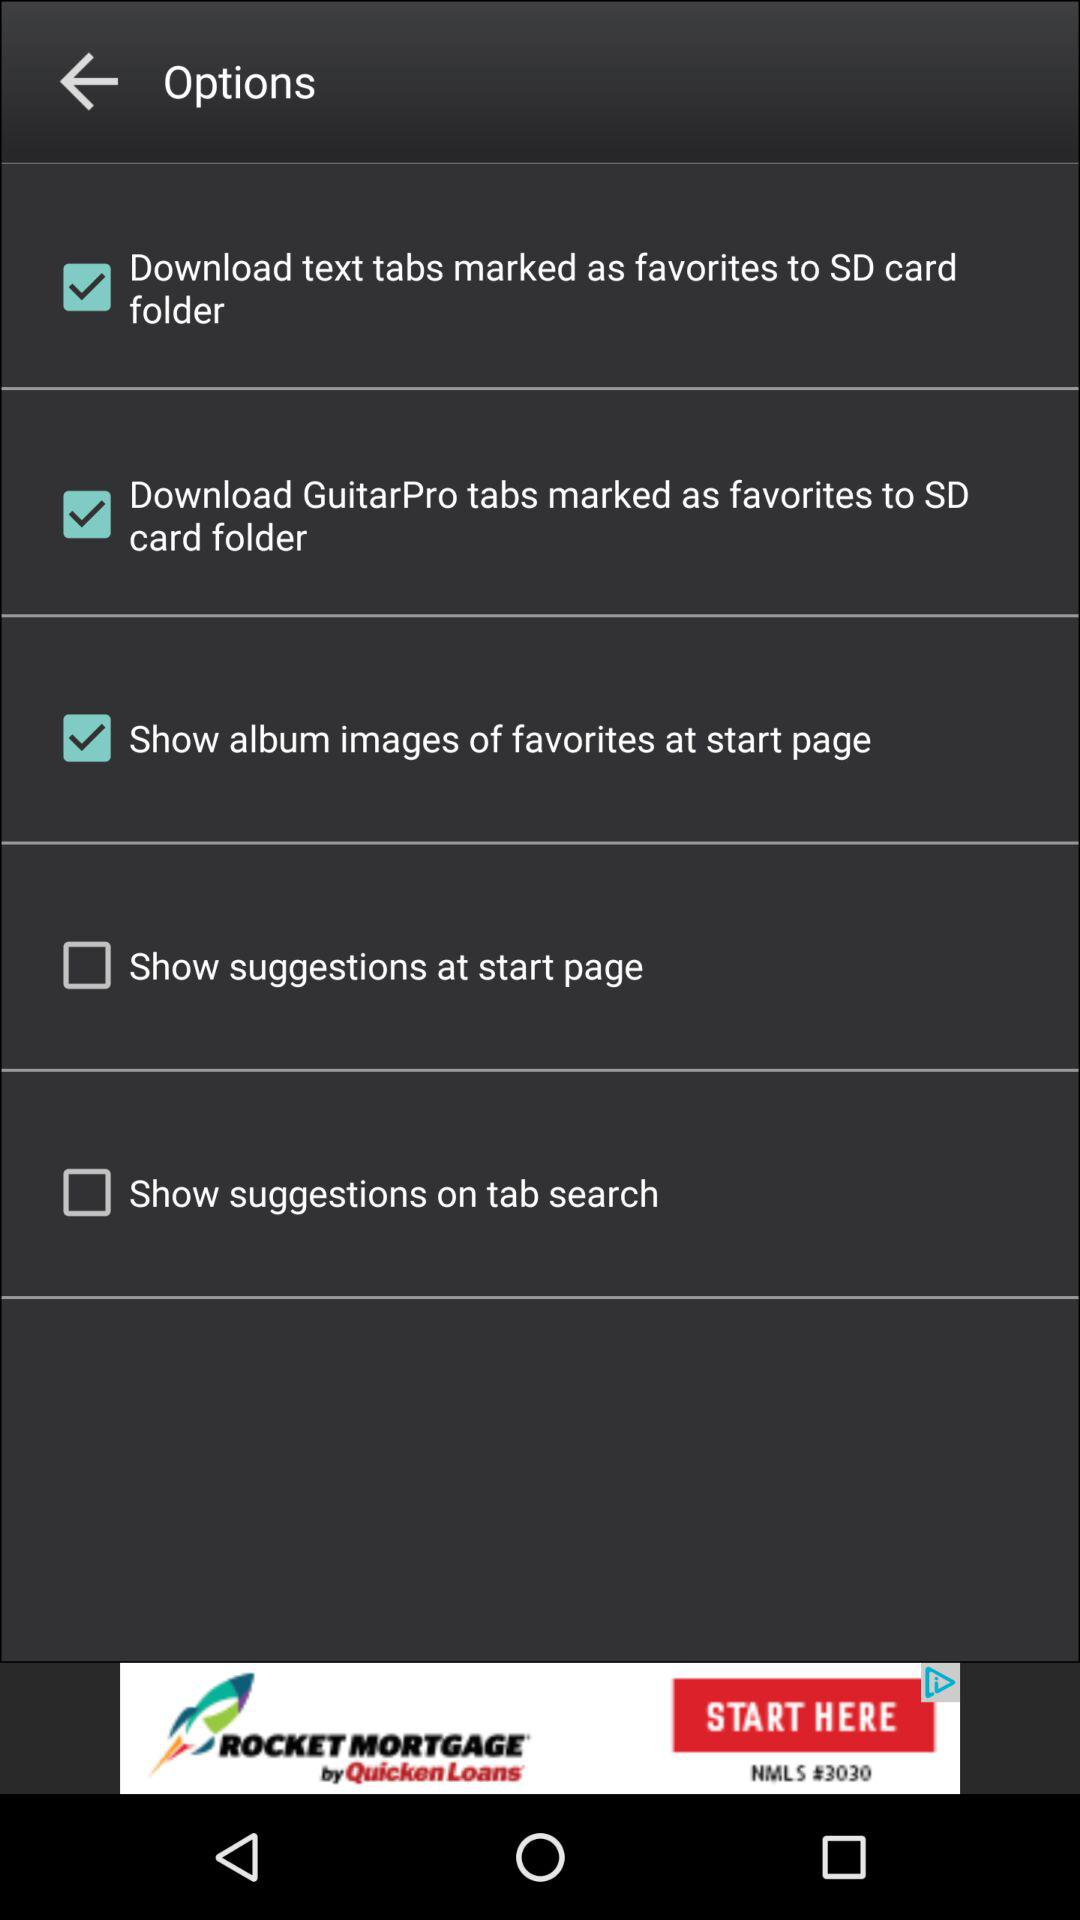How many options can be configured in the options menu?
Answer the question using a single word or phrase. 5 